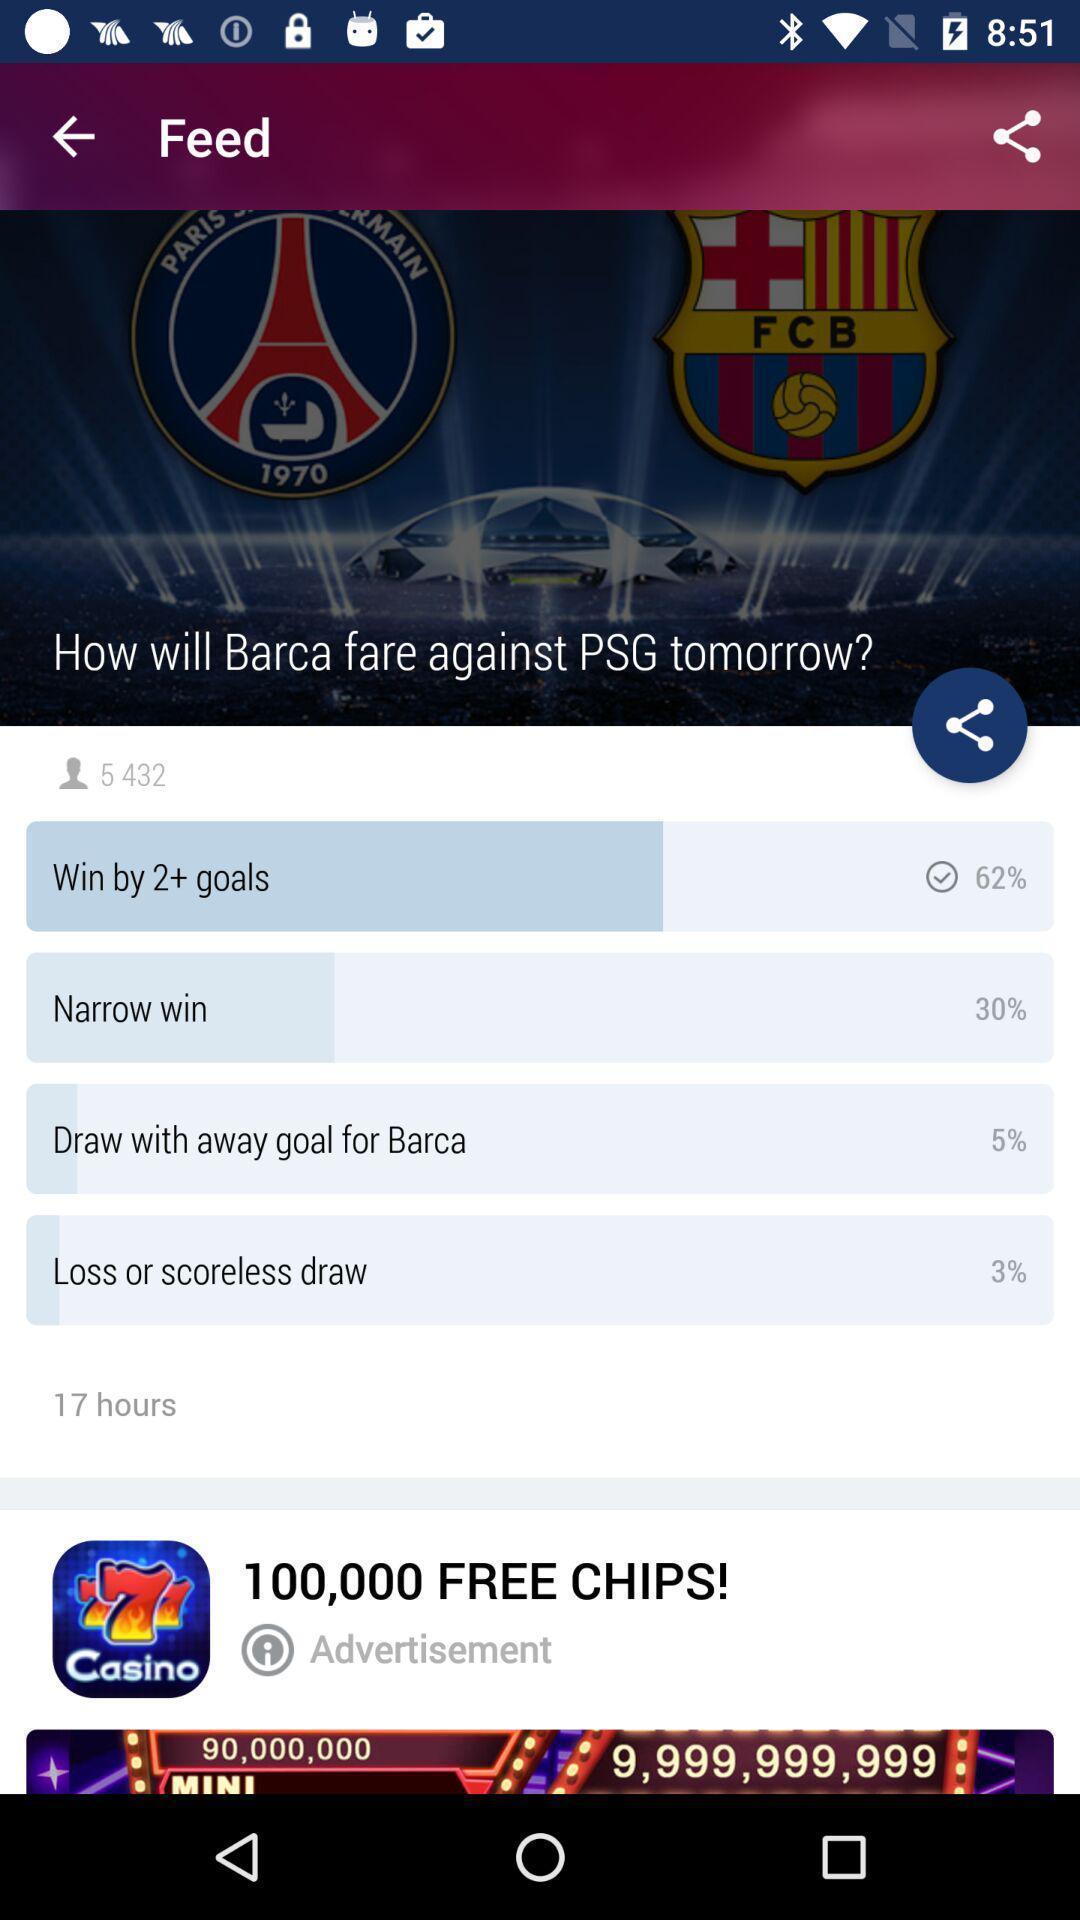Explain the elements present in this screenshot. Page with feed of a football game. 